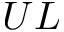<formula> <loc_0><loc_0><loc_500><loc_500>U L</formula> 